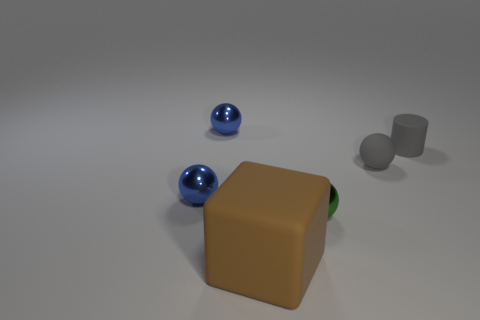There is a tiny thing that is made of the same material as the cylinder; what shape is it?
Offer a very short reply. Sphere. What size is the rubber thing that is left of the tiny metal ball on the right side of the large brown matte thing?
Give a very brief answer. Large. What number of things are either tiny rubber things that are on the left side of the small gray cylinder or small gray objects that are to the right of the rubber ball?
Your answer should be very brief. 2. Are there fewer small green objects than small blue shiny balls?
Your response must be concise. Yes. What number of objects are either gray things or small things?
Provide a short and direct response. 5. Does the green object have the same shape as the brown rubber thing?
Your answer should be compact. No. Do the metal ball on the right side of the big rubber block and the brown matte thing in front of the rubber cylinder have the same size?
Your answer should be very brief. No. There is a object that is left of the tiny rubber ball and right of the matte cube; what is it made of?
Make the answer very short. Metal. Are there any other things that are the same color as the cube?
Ensure brevity in your answer.  No. Are there fewer metallic things that are in front of the green sphere than tiny blue cylinders?
Your answer should be very brief. No. 